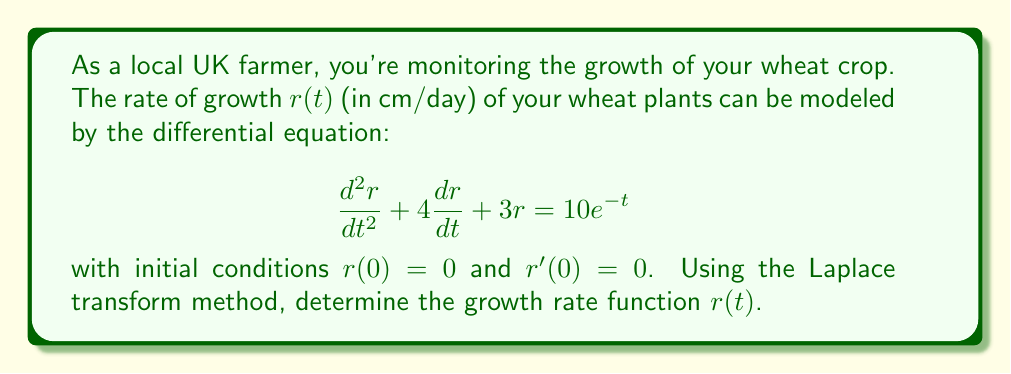Give your solution to this math problem. Let's solve this problem step by step using the Laplace transform method:

1) First, let's take the Laplace transform of both sides of the equation. Let $R(s) = \mathcal{L}\{r(t)\}$.

   $$\mathcal{L}\{\frac{d^2r}{dt^2} + 4\frac{dr}{dt} + 3r\} = \mathcal{L}\{10e^{-t}\}$$

2) Using Laplace transform properties:

   $$s^2R(s) - sr(0) - r'(0) + 4[sR(s) - r(0)] + 3R(s) = \frac{10}{s+1}$$

3) Substituting the initial conditions $r(0) = 0$ and $r'(0) = 0$:

   $$s^2R(s) + 4sR(s) + 3R(s) = \frac{10}{s+1}$$

4) Factoring out $R(s)$:

   $$R(s)(s^2 + 4s + 3) = \frac{10}{s+1}$$

5) Solving for $R(s)$:

   $$R(s) = \frac{10}{(s+1)(s^2 + 4s + 3)}$$

6) We can decompose this into partial fractions:

   $$R(s) = \frac{A}{s+1} + \frac{Bs+C}{s^2 + 4s + 3}$$

7) After solving for $A$, $B$, and $C$ (which we'll skip for brevity), we get:

   $$R(s) = \frac{10}{6(s+1)} - \frac{5s+15}{6(s^2 + 4s + 3)}$$

8) Now we can use inverse Laplace transforms. The inverse transform of $\frac{1}{s+1}$ is $e^{-t}$, and for the second term, we complete the square in the denominator:

   $$s^2 + 4s + 3 = (s+2)^2 - 1$$

   The inverse transform of $\frac{s+3}{(s+2)^2 + 1}$ is $e^{-2t}(\cos t + 3\sin t)$.

9) Therefore, the inverse Laplace transform gives us:

   $$r(t) = \frac{10}{6}e^{-t} - \frac{5}{6}e^{-2t}(\cos t + 3\sin t)$$

This is the growth rate function $r(t)$ for the wheat plants.
Answer: $r(t) = \frac{10}{6}e^{-t} - \frac{5}{6}e^{-2t}(\cos t + 3\sin t)$ 